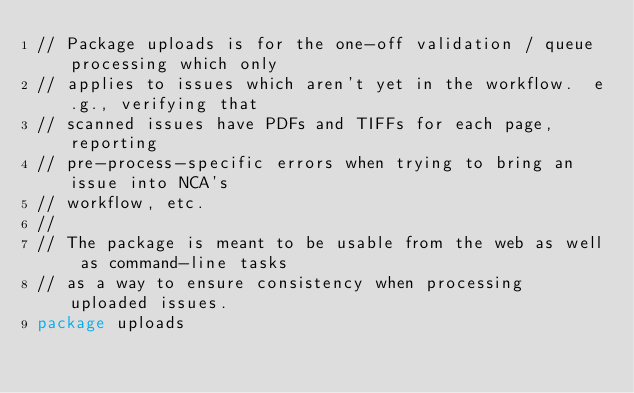<code> <loc_0><loc_0><loc_500><loc_500><_Go_>// Package uploads is for the one-off validation / queue processing which only
// applies to issues which aren't yet in the workflow.  e.g., verifying that
// scanned issues have PDFs and TIFFs for each page, reporting
// pre-process-specific errors when trying to bring an issue into NCA's
// workflow, etc.
//
// The package is meant to be usable from the web as well as command-line tasks
// as a way to ensure consistency when processing uploaded issues.
package uploads
</code> 